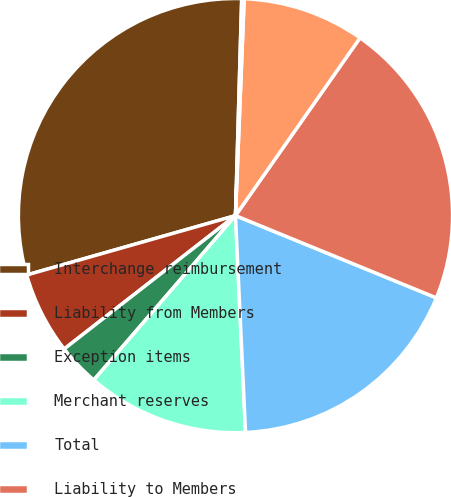Convert chart. <chart><loc_0><loc_0><loc_500><loc_500><pie_chart><fcel>Interchange reimbursement<fcel>Liability from Members<fcel>Exception items<fcel>Merchant reserves<fcel>Total<fcel>Liability to Members<fcel>Fair value of guarantees of<fcel>Reserves for sales allowances<nl><fcel>29.87%<fcel>6.12%<fcel>3.15%<fcel>12.06%<fcel>18.08%<fcel>21.46%<fcel>9.09%<fcel>0.18%<nl></chart> 